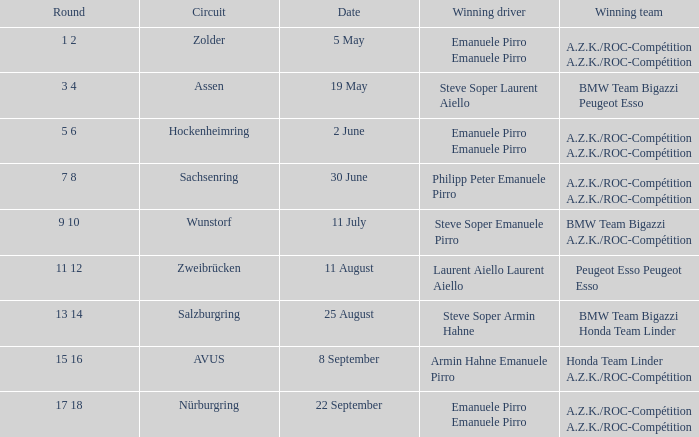Who is the triumphant driver of the race on 5 may? Emanuele Pirro Emanuele Pirro. 